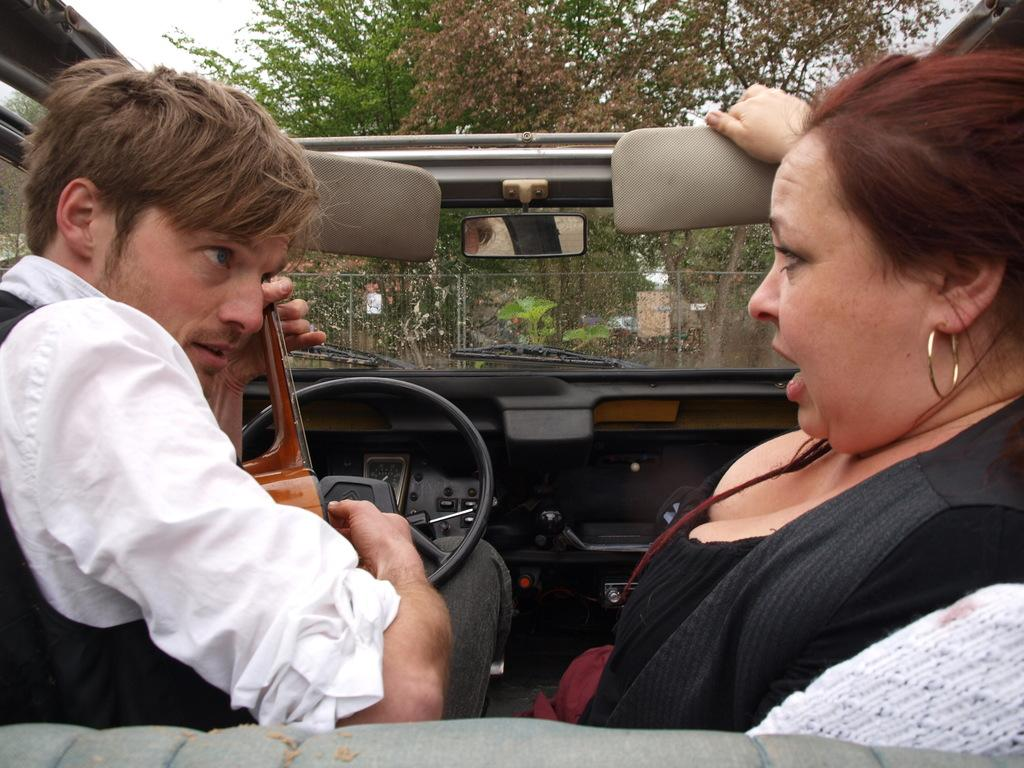What is the main subject of the image? The main subject of the image is a car. Who is inside the car? There is a man holding the steering wheel and a woman sitting in the car. Where are the man and woman positioned in the car? The man is on the left side of the car, holding the steering wheel, and the woman is on the right side of the car. What type of art is displayed on the committee in the image? There is no committee or art present in the image; it features a car with a man and a woman inside. Can you tell me how many ducks are visible in the image? There are no ducks present in the image. 